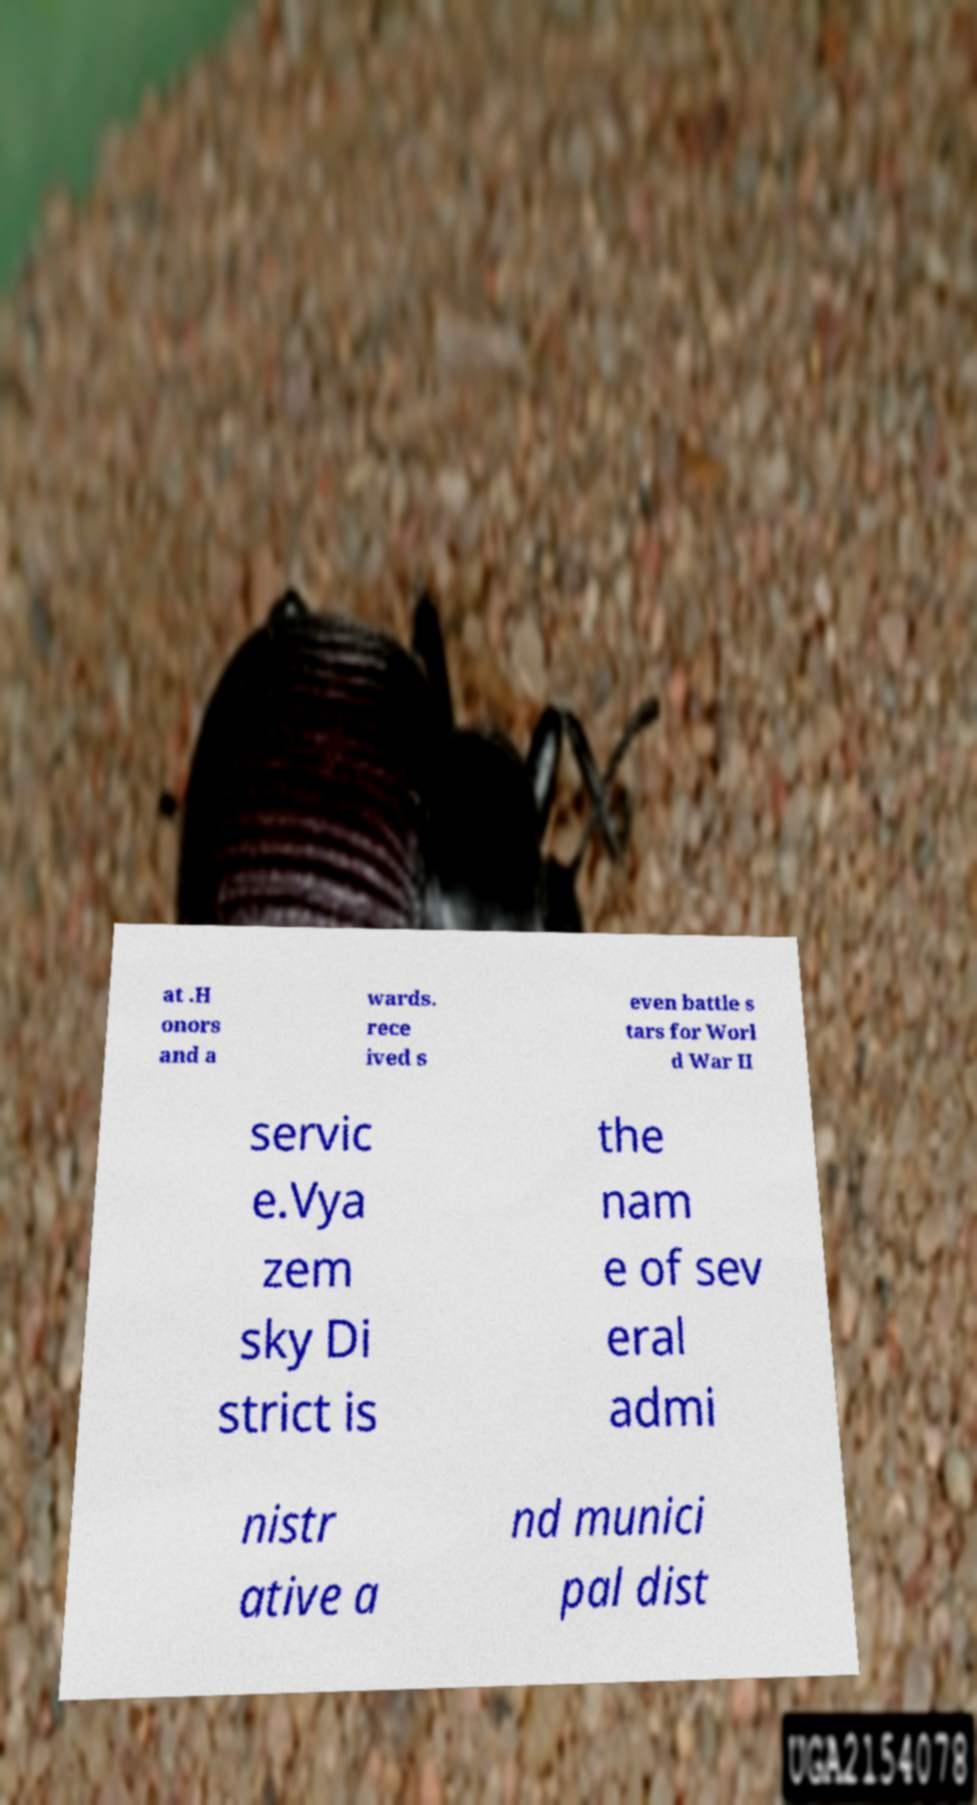Can you accurately transcribe the text from the provided image for me? at .H onors and a wards. rece ived s even battle s tars for Worl d War II servic e.Vya zem sky Di strict is the nam e of sev eral admi nistr ative a nd munici pal dist 